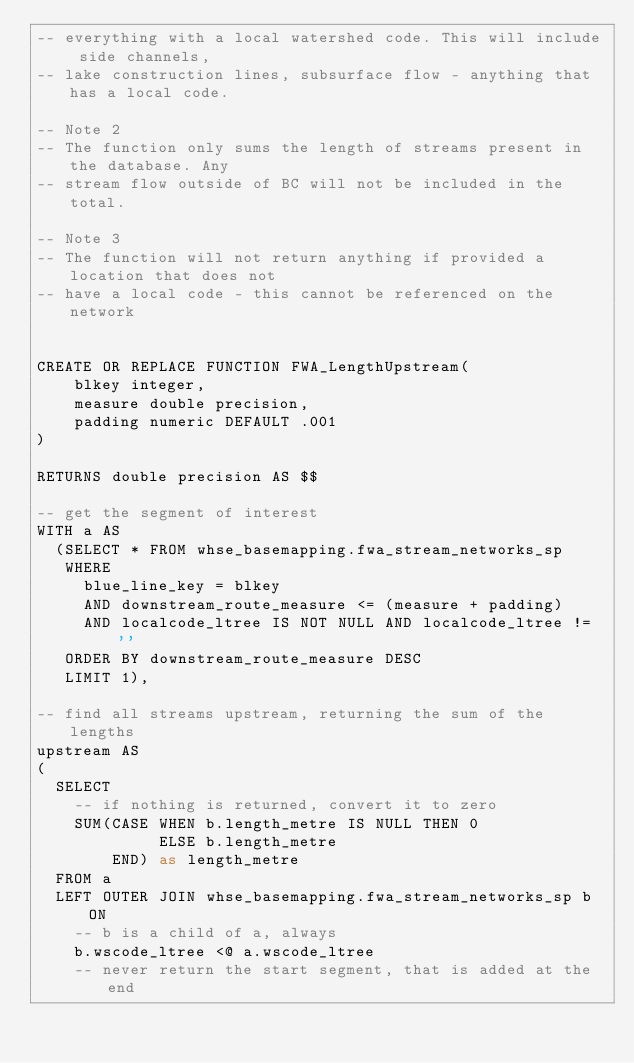Convert code to text. <code><loc_0><loc_0><loc_500><loc_500><_SQL_>-- everything with a local watershed code. This will include side channels,
-- lake construction lines, subsurface flow - anything that has a local code.

-- Note 2
-- The function only sums the length of streams present in the database. Any
-- stream flow outside of BC will not be included in the total.

-- Note 3
-- The function will not return anything if provided a location that does not
-- have a local code - this cannot be referenced on the network


CREATE OR REPLACE FUNCTION FWA_LengthUpstream(
    blkey integer,
    measure double precision,
    padding numeric DEFAULT .001
)

RETURNS double precision AS $$

-- get the segment of interest
WITH a AS
  (SELECT * FROM whse_basemapping.fwa_stream_networks_sp
   WHERE
     blue_line_key = blkey
     AND downstream_route_measure <= (measure + padding)
     AND localcode_ltree IS NOT NULL AND localcode_ltree != ''
   ORDER BY downstream_route_measure DESC
   LIMIT 1),

-- find all streams upstream, returning the sum of the lengths
upstream AS
(
  SELECT
    -- if nothing is returned, convert it to zero
    SUM(CASE WHEN b.length_metre IS NULL THEN 0
             ELSE b.length_metre
        END) as length_metre
  FROM a
  LEFT OUTER JOIN whse_basemapping.fwa_stream_networks_sp b ON
    -- b is a child of a, always
    b.wscode_ltree <@ a.wscode_ltree
    -- never return the start segment, that is added at the end</code> 